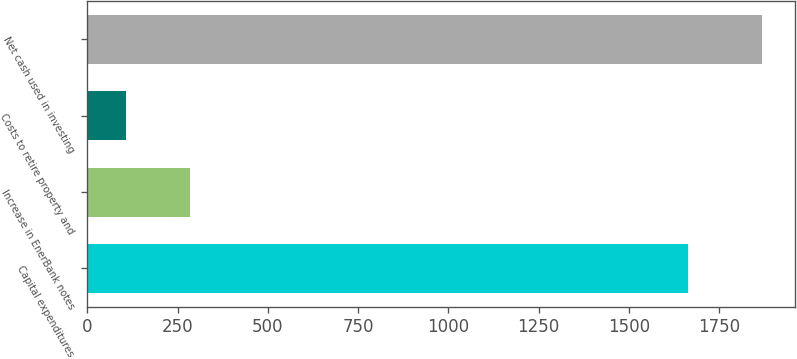<chart> <loc_0><loc_0><loc_500><loc_500><bar_chart><fcel>Capital expenditures<fcel>Increase in EnerBank notes<fcel>Costs to retire property and<fcel>Net cash used in investing<nl><fcel>1665<fcel>284<fcel>108<fcel>1868<nl></chart> 